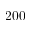Convert formula to latex. <formula><loc_0><loc_0><loc_500><loc_500>2 0 0</formula> 